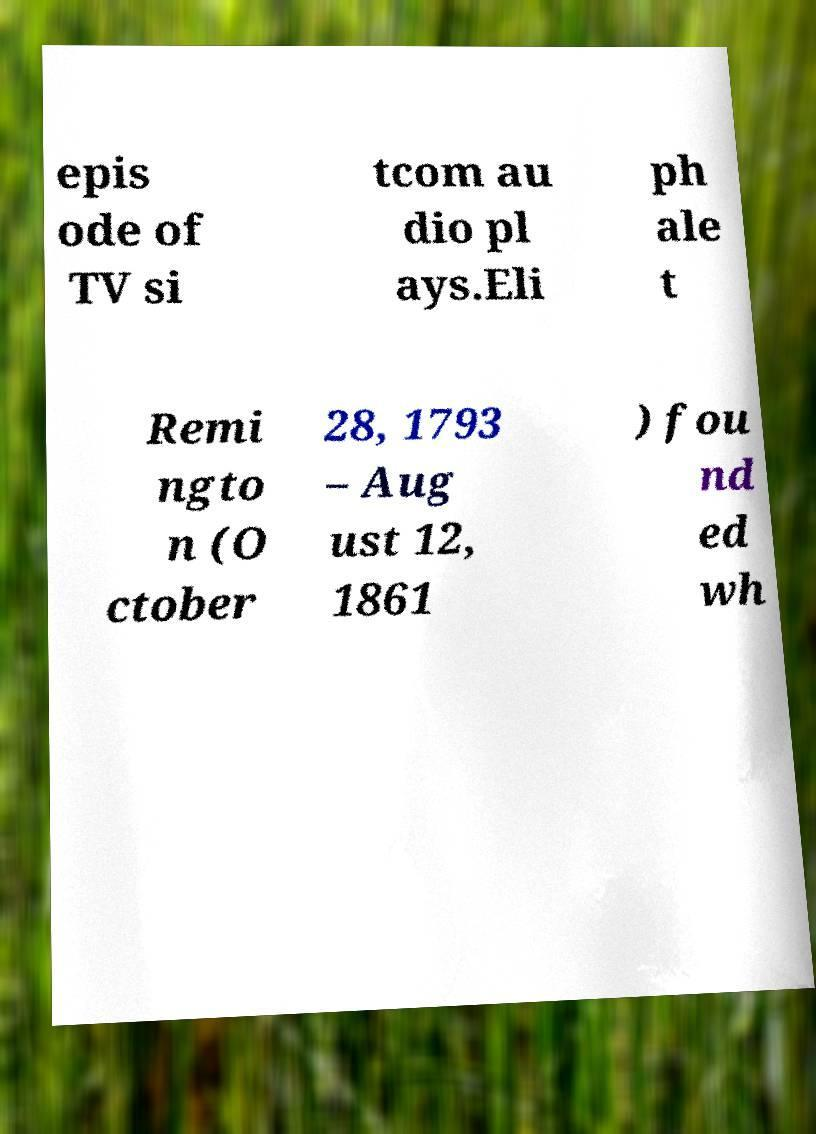Could you extract and type out the text from this image? epis ode of TV si tcom au dio pl ays.Eli ph ale t Remi ngto n (O ctober 28, 1793 – Aug ust 12, 1861 ) fou nd ed wh 